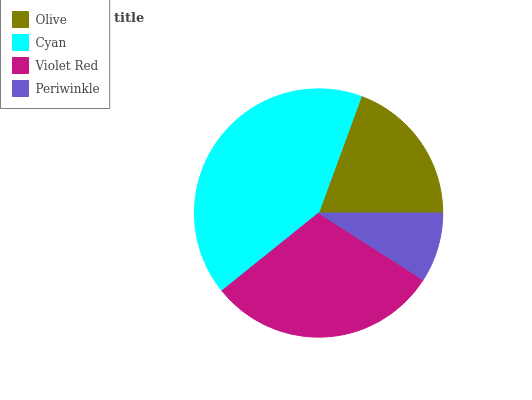Is Periwinkle the minimum?
Answer yes or no. Yes. Is Cyan the maximum?
Answer yes or no. Yes. Is Violet Red the minimum?
Answer yes or no. No. Is Violet Red the maximum?
Answer yes or no. No. Is Cyan greater than Violet Red?
Answer yes or no. Yes. Is Violet Red less than Cyan?
Answer yes or no. Yes. Is Violet Red greater than Cyan?
Answer yes or no. No. Is Cyan less than Violet Red?
Answer yes or no. No. Is Violet Red the high median?
Answer yes or no. Yes. Is Olive the low median?
Answer yes or no. Yes. Is Cyan the high median?
Answer yes or no. No. Is Violet Red the low median?
Answer yes or no. No. 